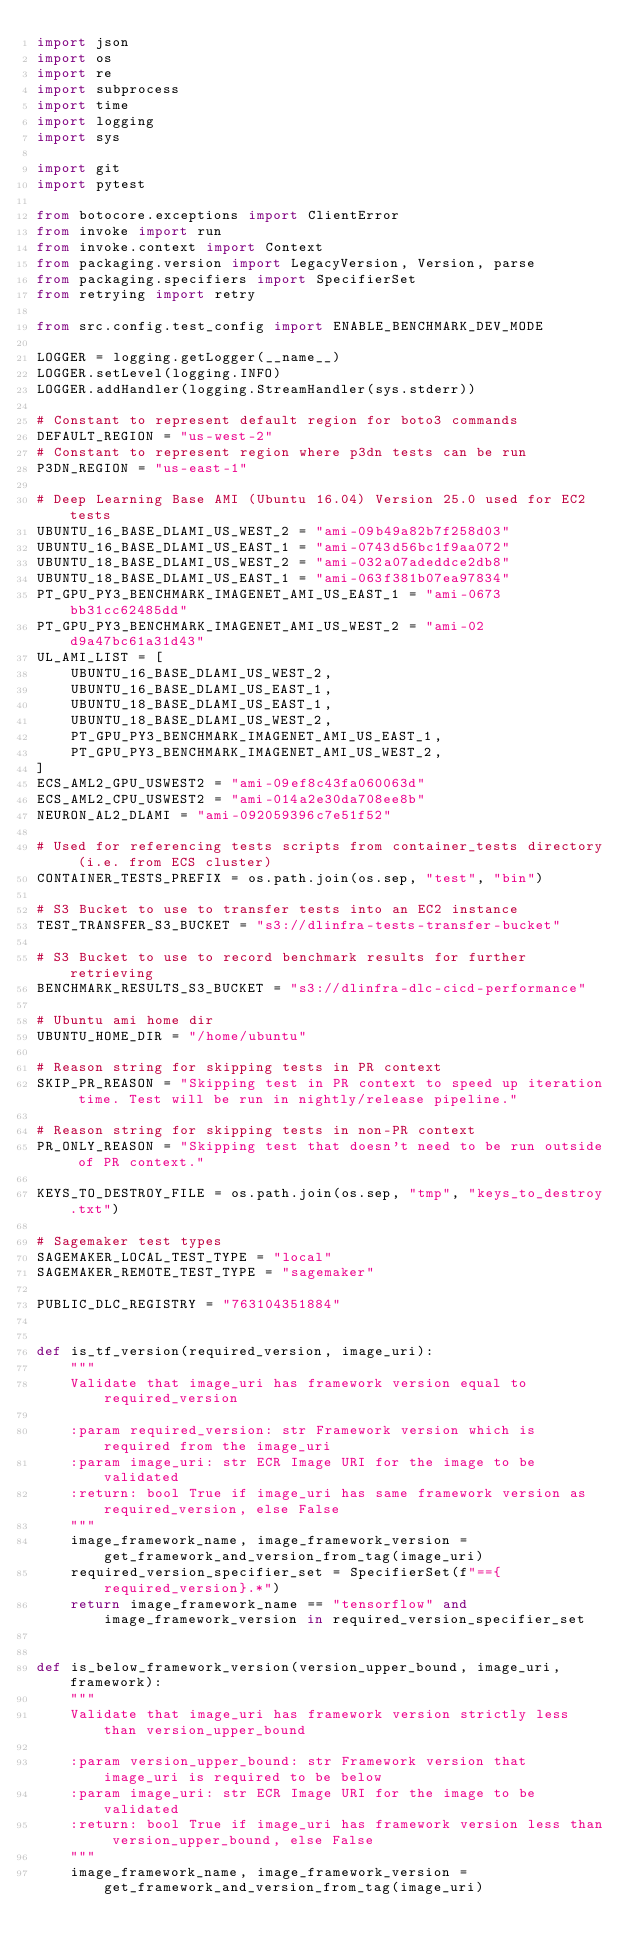<code> <loc_0><loc_0><loc_500><loc_500><_Python_>import json
import os
import re
import subprocess
import time
import logging
import sys

import git
import pytest

from botocore.exceptions import ClientError
from invoke import run
from invoke.context import Context
from packaging.version import LegacyVersion, Version, parse
from packaging.specifiers import SpecifierSet
from retrying import retry

from src.config.test_config import ENABLE_BENCHMARK_DEV_MODE

LOGGER = logging.getLogger(__name__)
LOGGER.setLevel(logging.INFO)
LOGGER.addHandler(logging.StreamHandler(sys.stderr))

# Constant to represent default region for boto3 commands
DEFAULT_REGION = "us-west-2"
# Constant to represent region where p3dn tests can be run
P3DN_REGION = "us-east-1"

# Deep Learning Base AMI (Ubuntu 16.04) Version 25.0 used for EC2 tests
UBUNTU_16_BASE_DLAMI_US_WEST_2 = "ami-09b49a82b7f258d03"
UBUNTU_16_BASE_DLAMI_US_EAST_1 = "ami-0743d56bc1f9aa072"
UBUNTU_18_BASE_DLAMI_US_WEST_2 = "ami-032a07adeddce2db8"
UBUNTU_18_BASE_DLAMI_US_EAST_1 = "ami-063f381b07ea97834"
PT_GPU_PY3_BENCHMARK_IMAGENET_AMI_US_EAST_1 = "ami-0673bb31cc62485dd"
PT_GPU_PY3_BENCHMARK_IMAGENET_AMI_US_WEST_2 = "ami-02d9a47bc61a31d43"
UL_AMI_LIST = [
    UBUNTU_16_BASE_DLAMI_US_WEST_2,
    UBUNTU_16_BASE_DLAMI_US_EAST_1,
    UBUNTU_18_BASE_DLAMI_US_EAST_1,
    UBUNTU_18_BASE_DLAMI_US_WEST_2,
    PT_GPU_PY3_BENCHMARK_IMAGENET_AMI_US_EAST_1,
    PT_GPU_PY3_BENCHMARK_IMAGENET_AMI_US_WEST_2,
]
ECS_AML2_GPU_USWEST2 = "ami-09ef8c43fa060063d"
ECS_AML2_CPU_USWEST2 = "ami-014a2e30da708ee8b"
NEURON_AL2_DLAMI = "ami-092059396c7e51f52"

# Used for referencing tests scripts from container_tests directory (i.e. from ECS cluster)
CONTAINER_TESTS_PREFIX = os.path.join(os.sep, "test", "bin")

# S3 Bucket to use to transfer tests into an EC2 instance
TEST_TRANSFER_S3_BUCKET = "s3://dlinfra-tests-transfer-bucket"

# S3 Bucket to use to record benchmark results for further retrieving
BENCHMARK_RESULTS_S3_BUCKET = "s3://dlinfra-dlc-cicd-performance"

# Ubuntu ami home dir
UBUNTU_HOME_DIR = "/home/ubuntu"

# Reason string for skipping tests in PR context
SKIP_PR_REASON = "Skipping test in PR context to speed up iteration time. Test will be run in nightly/release pipeline."

# Reason string for skipping tests in non-PR context
PR_ONLY_REASON = "Skipping test that doesn't need to be run outside of PR context."

KEYS_TO_DESTROY_FILE = os.path.join(os.sep, "tmp", "keys_to_destroy.txt")

# Sagemaker test types
SAGEMAKER_LOCAL_TEST_TYPE = "local"
SAGEMAKER_REMOTE_TEST_TYPE = "sagemaker"

PUBLIC_DLC_REGISTRY = "763104351884"


def is_tf_version(required_version, image_uri):
    """
    Validate that image_uri has framework version equal to required_version

    :param required_version: str Framework version which is required from the image_uri
    :param image_uri: str ECR Image URI for the image to be validated
    :return: bool True if image_uri has same framework version as required_version, else False
    """
    image_framework_name, image_framework_version = get_framework_and_version_from_tag(image_uri)
    required_version_specifier_set = SpecifierSet(f"=={required_version}.*")
    return image_framework_name == "tensorflow" and image_framework_version in required_version_specifier_set


def is_below_framework_version(version_upper_bound, image_uri, framework):
    """
    Validate that image_uri has framework version strictly less than version_upper_bound

    :param version_upper_bound: str Framework version that image_uri is required to be below
    :param image_uri: str ECR Image URI for the image to be validated
    :return: bool True if image_uri has framework version less than version_upper_bound, else False
    """
    image_framework_name, image_framework_version = get_framework_and_version_from_tag(image_uri)</code> 